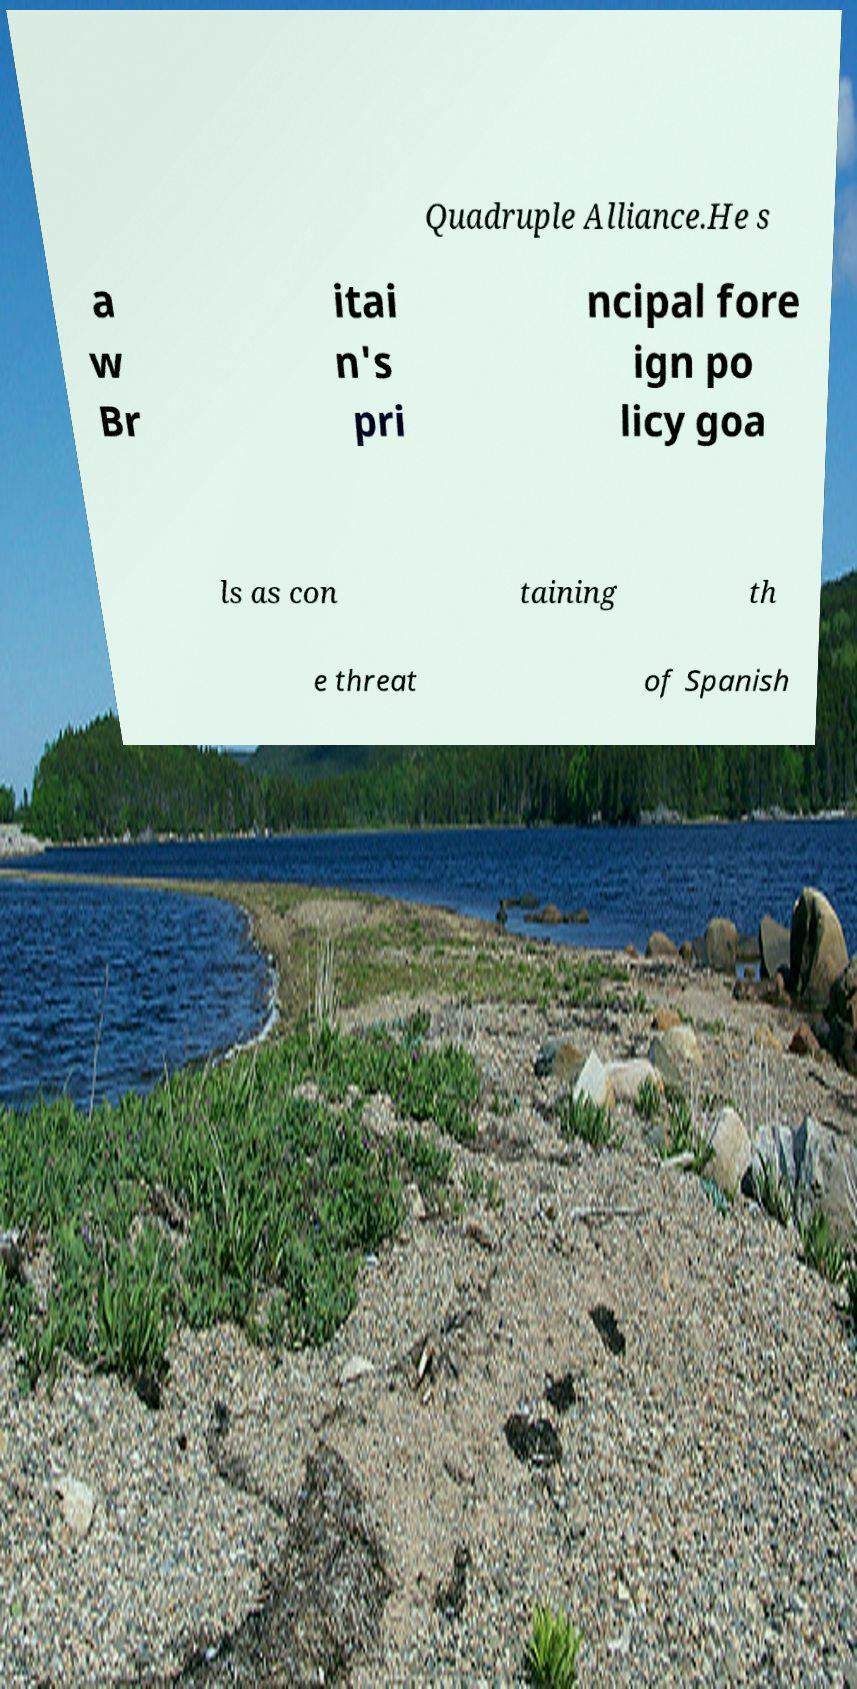Could you assist in decoding the text presented in this image and type it out clearly? Quadruple Alliance.He s a w Br itai n's pri ncipal fore ign po licy goa ls as con taining th e threat of Spanish 